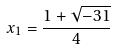Convert formula to latex. <formula><loc_0><loc_0><loc_500><loc_500>x _ { 1 } = \frac { 1 + \sqrt { - 3 1 } } { 4 }</formula> 